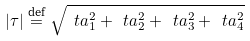<formula> <loc_0><loc_0><loc_500><loc_500>| \tau | \stackrel { \text {def} } { = } \sqrt { \ t a _ { 1 } ^ { 2 } + \ t a _ { 2 } ^ { 2 } + \ t a _ { 3 } ^ { 2 } + \ t a ^ { 2 } _ { 4 } }</formula> 